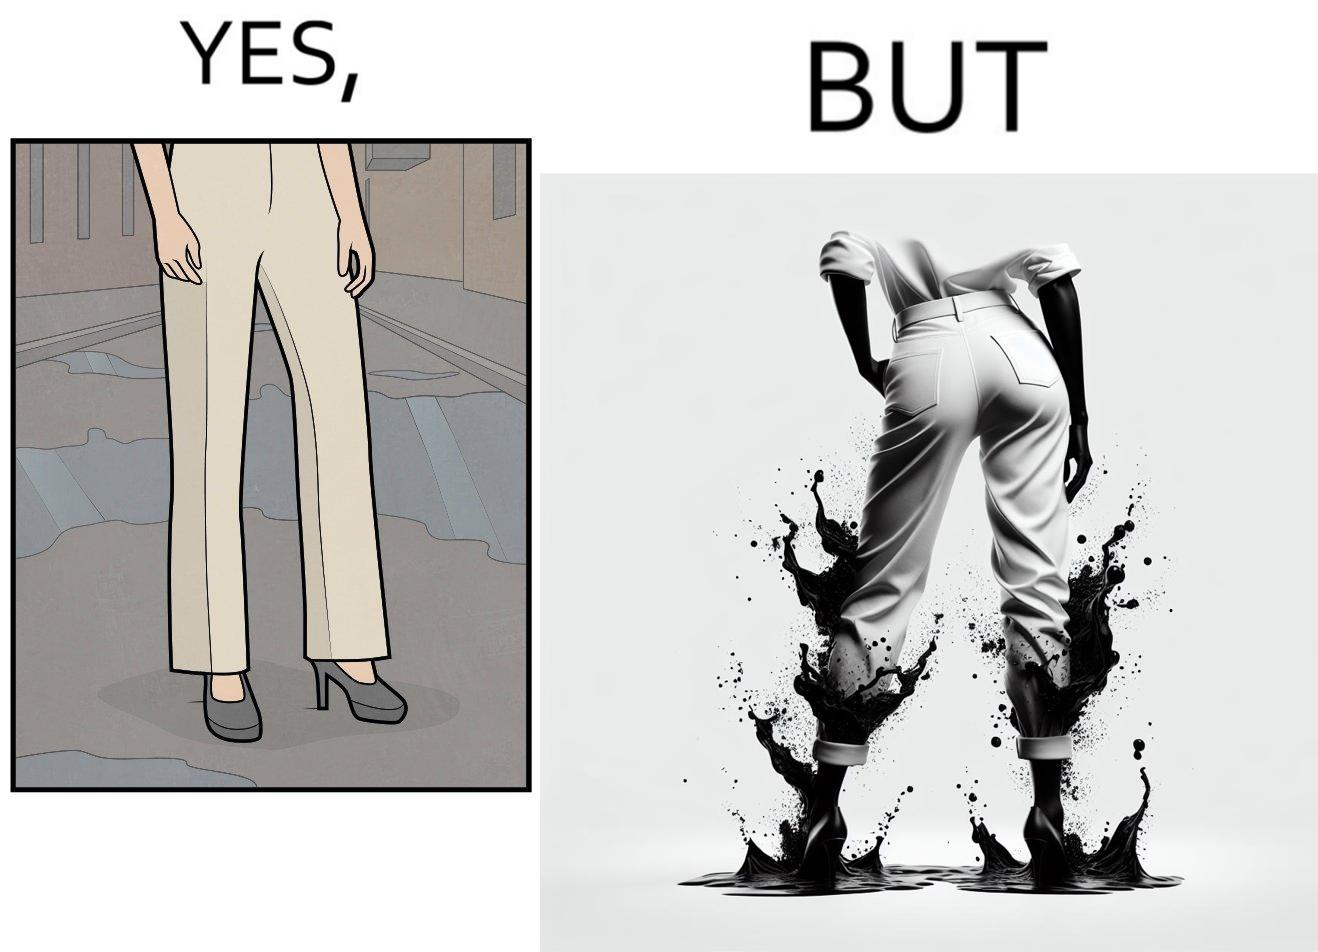Is this image satirical or non-satirical? Yes, this image is satirical. 